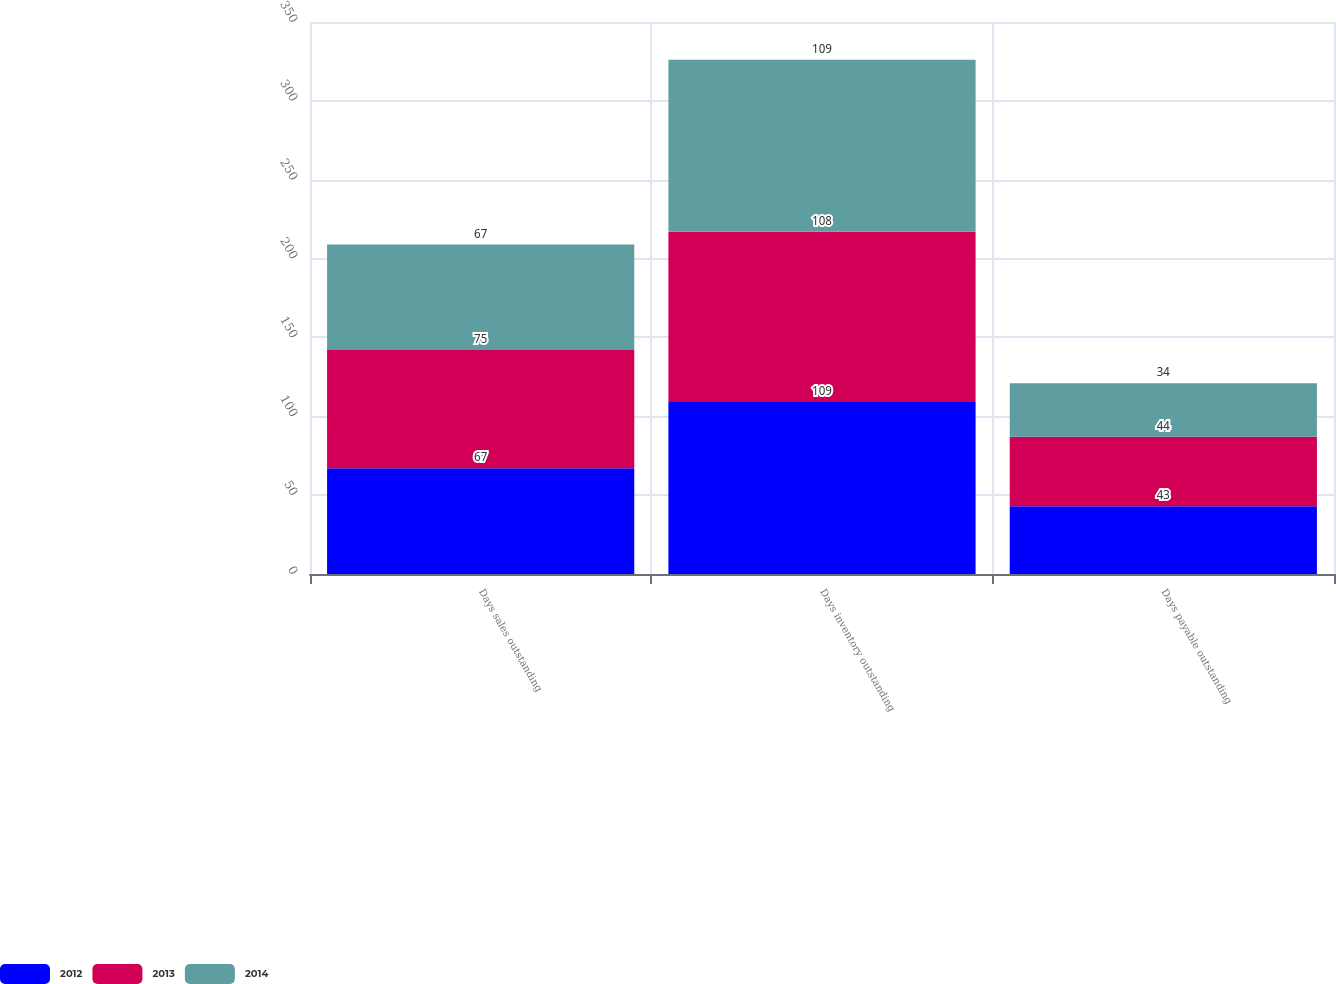<chart> <loc_0><loc_0><loc_500><loc_500><stacked_bar_chart><ecel><fcel>Days sales outstanding<fcel>Days inventory outstanding<fcel>Days payable outstanding<nl><fcel>2012<fcel>67<fcel>109<fcel>43<nl><fcel>2013<fcel>75<fcel>108<fcel>44<nl><fcel>2014<fcel>67<fcel>109<fcel>34<nl></chart> 